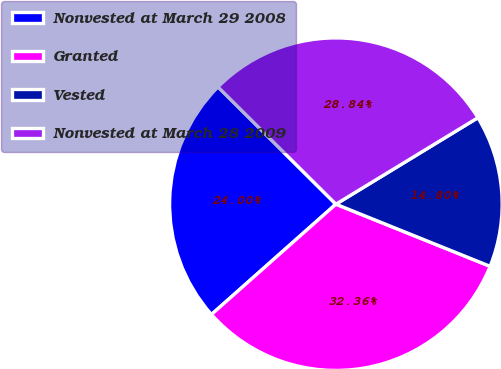Convert chart. <chart><loc_0><loc_0><loc_500><loc_500><pie_chart><fcel>Nonvested at March 29 2008<fcel>Granted<fcel>Vested<fcel>Nonvested at March 28 2009<nl><fcel>24.0%<fcel>32.36%<fcel>14.8%<fcel>28.84%<nl></chart> 